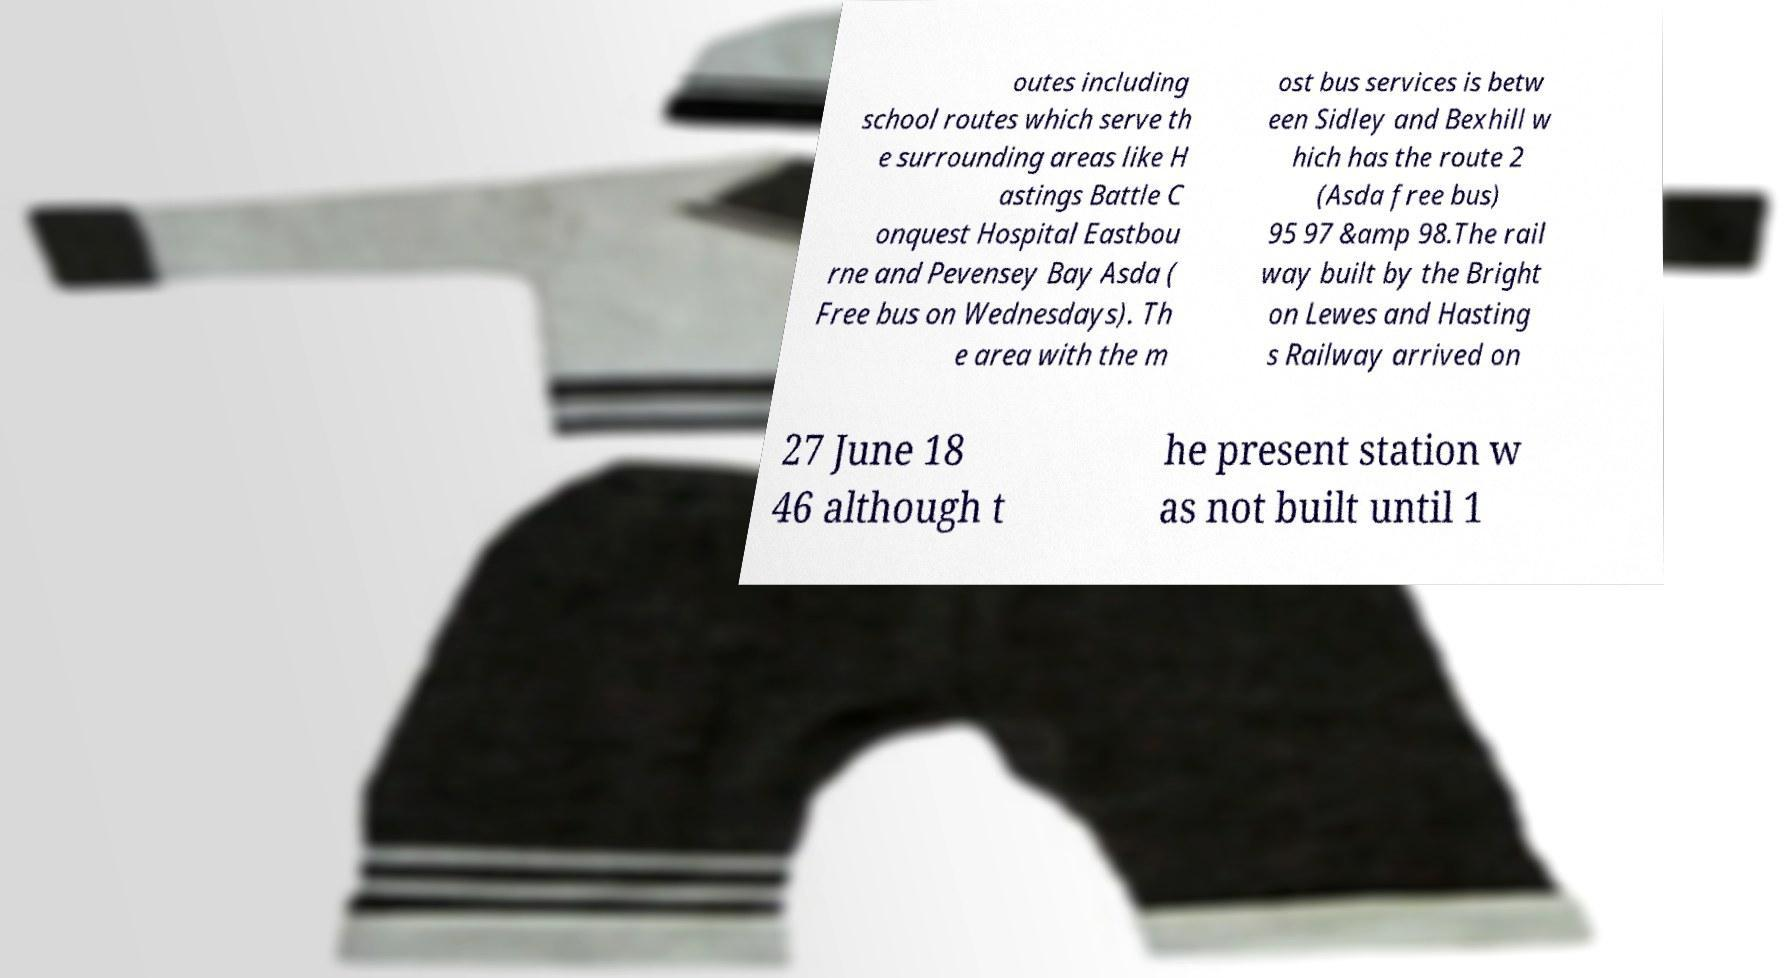I need the written content from this picture converted into text. Can you do that? outes including school routes which serve th e surrounding areas like H astings Battle C onquest Hospital Eastbou rne and Pevensey Bay Asda ( Free bus on Wednesdays). Th e area with the m ost bus services is betw een Sidley and Bexhill w hich has the route 2 (Asda free bus) 95 97 &amp 98.The rail way built by the Bright on Lewes and Hasting s Railway arrived on 27 June 18 46 although t he present station w as not built until 1 